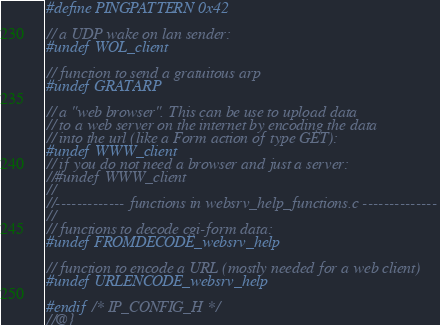<code> <loc_0><loc_0><loc_500><loc_500><_C_>#define PINGPATTERN 0x42

// a UDP wake on lan sender:
#undef WOL_client

// function to send a gratuitous arp
#undef GRATARP

// a "web browser". This can be use to upload data
// to a web server on the internet by encoding the data 
// into the url (like a Form action of type GET):
#undef WWW_client
// if you do not need a browser and just a server:
//#undef WWW_client
//
//------------- functions in websrv_help_functions.c --------------
//
// functions to decode cgi-form data:
#undef FROMDECODE_websrv_help

// function to encode a URL (mostly needed for a web client)
#undef URLENCODE_websrv_help

#endif /* IP_CONFIG_H */
//@}
</code> 